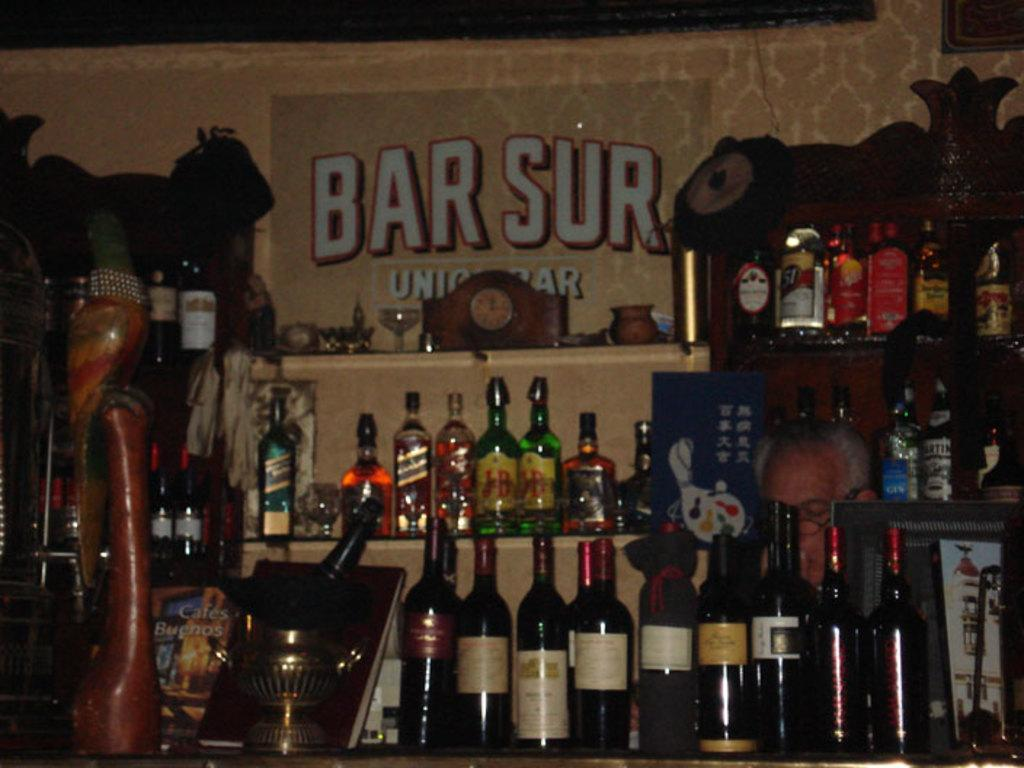What types of bottles are visible in the image? There are wine bottles and beer bottles in the image. How are the bottles arranged in the image? The bottles are placed in a rack. What can be seen on the wall in the image? There is a poster attached to the wall in the image. Who is present in the image? There is a man in the image. What is located on the left side of the image? There is a wooden object on the left side of the image. How does the man account for his mom's absence in the image? There is no mention of the man's mom or her absence in the image, so it cannot be determined how he would account for it. 